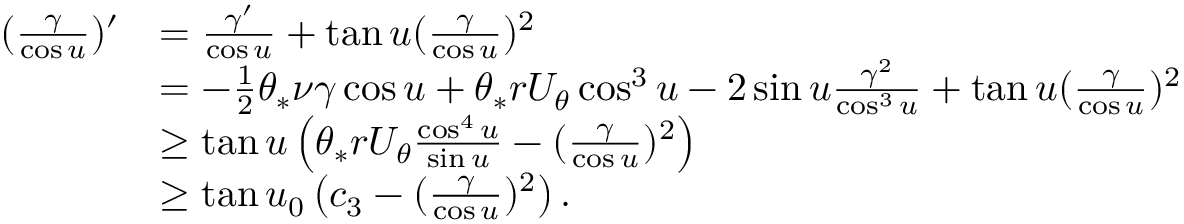<formula> <loc_0><loc_0><loc_500><loc_500>\begin{array} { r l } { ( \frac { \gamma } { \cos u } ) ^ { \prime } } & { = \frac { \gamma ^ { \prime } } { \cos u } + \tan u ( \frac { \gamma } { \cos u } ) ^ { 2 } } \\ & { = - \frac { 1 } { 2 } \theta _ { * } \nu \gamma \cos u + \theta _ { * } r U _ { \theta } \cos ^ { 3 } u - 2 \sin u \frac { \gamma ^ { 2 } } { \cos ^ { 3 } u } + \tan u ( \frac { \gamma } { \cos u } ) ^ { 2 } } \\ & { \geq \tan u \left ( \theta _ { * } r U _ { \theta } \frac { \cos ^ { 4 } u } { \sin u } - ( \frac { \gamma } { \cos u } ) ^ { 2 } \right ) } \\ & { \geq \tan u _ { 0 } \left ( c _ { 3 } - ( \frac { \gamma } { \cos u } ) ^ { 2 } \right ) . } \end{array}</formula> 